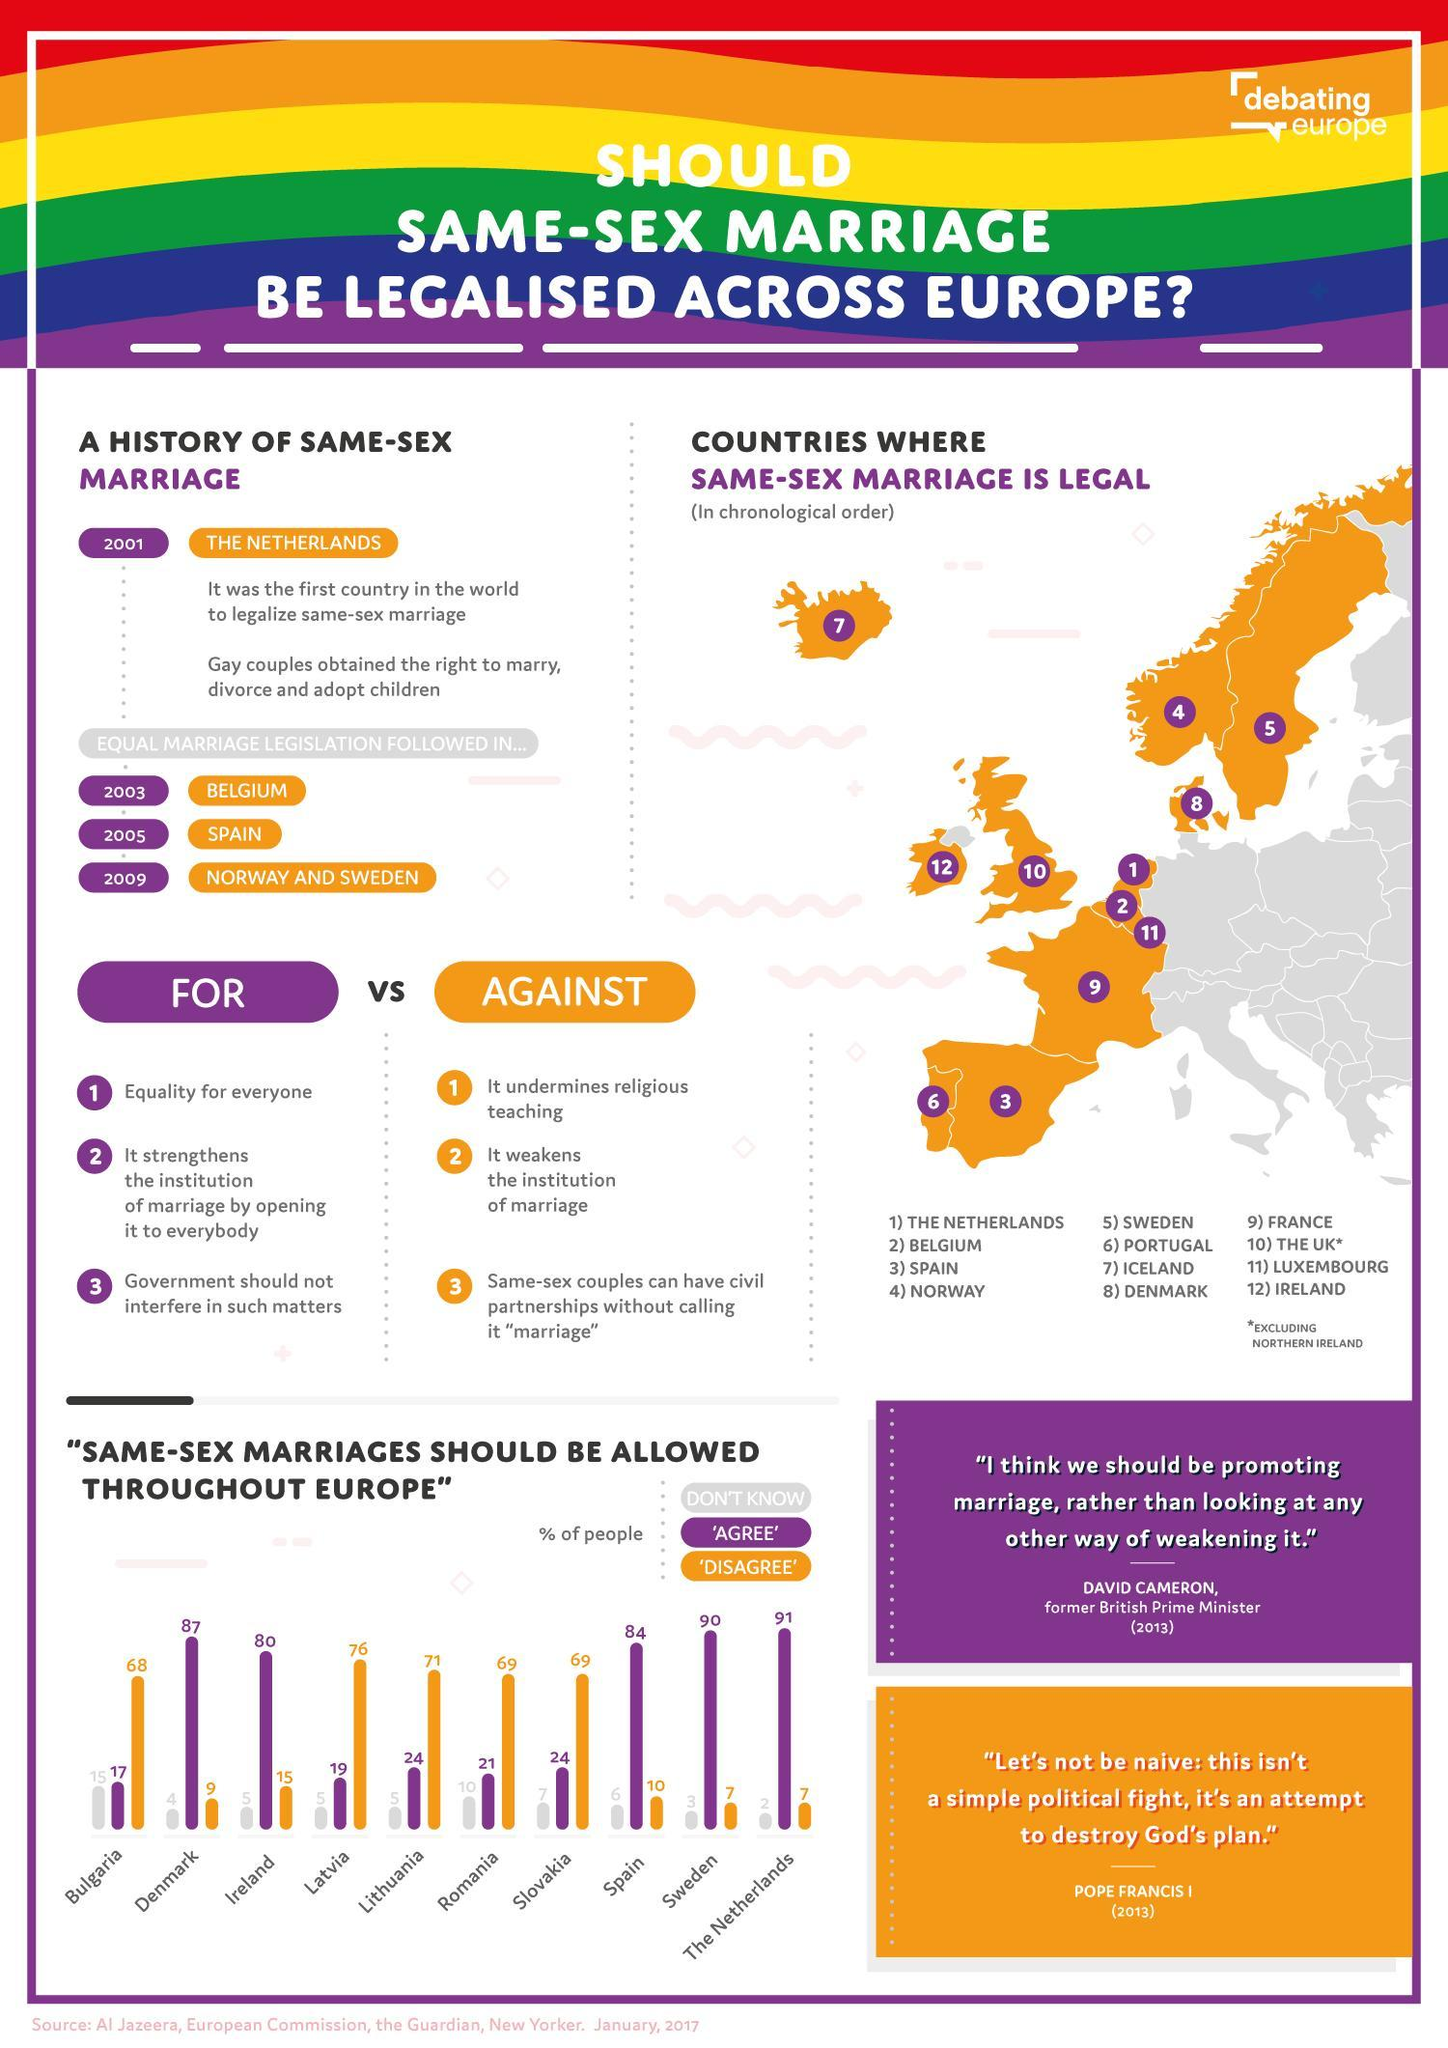How many countries have a majority of people agreeing to same sex marriage?
Answer the question with a short phrase. 5 Which countries have the least minority of people disagreeing to allow same sex marriage? The Netherlands, Sweden Which country has the least minority of population that agrees for same sex marriage? Bulgaria Which color is used in the bar chart to denote people who don't know if same sex marriage should be allowed in Europe,  purple, gray/ grey, or orange? gray/grey How many countries have a majority of people disagreeing for same sex marriage? 5 